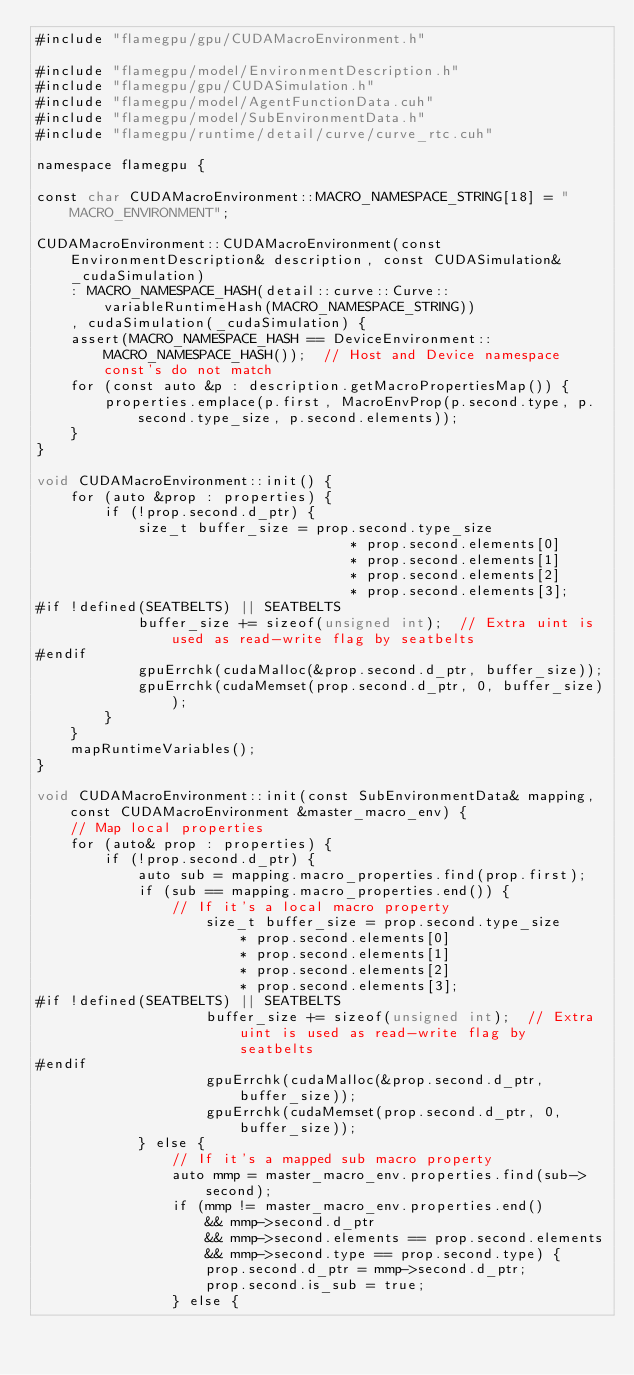<code> <loc_0><loc_0><loc_500><loc_500><_Cuda_>#include "flamegpu/gpu/CUDAMacroEnvironment.h"

#include "flamegpu/model/EnvironmentDescription.h"
#include "flamegpu/gpu/CUDASimulation.h"
#include "flamegpu/model/AgentFunctionData.cuh"
#include "flamegpu/model/SubEnvironmentData.h"
#include "flamegpu/runtime/detail/curve/curve_rtc.cuh"

namespace flamegpu {

const char CUDAMacroEnvironment::MACRO_NAMESPACE_STRING[18] = "MACRO_ENVIRONMENT";

CUDAMacroEnvironment::CUDAMacroEnvironment(const EnvironmentDescription& description, const CUDASimulation& _cudaSimulation)
    : MACRO_NAMESPACE_HASH(detail::curve::Curve::variableRuntimeHash(MACRO_NAMESPACE_STRING))
    , cudaSimulation(_cudaSimulation) {
    assert(MACRO_NAMESPACE_HASH == DeviceEnvironment::MACRO_NAMESPACE_HASH());  // Host and Device namespace const's do not match
    for (const auto &p : description.getMacroPropertiesMap()) {
        properties.emplace(p.first, MacroEnvProp(p.second.type, p.second.type_size, p.second.elements));
    }
}

void CUDAMacroEnvironment::init() {
    for (auto &prop : properties) {
        if (!prop.second.d_ptr) {
            size_t buffer_size = prop.second.type_size
                                     * prop.second.elements[0]
                                     * prop.second.elements[1]
                                     * prop.second.elements[2]
                                     * prop.second.elements[3];
#if !defined(SEATBELTS) || SEATBELTS
            buffer_size += sizeof(unsigned int);  // Extra uint is used as read-write flag by seatbelts
#endif
            gpuErrchk(cudaMalloc(&prop.second.d_ptr, buffer_size));
            gpuErrchk(cudaMemset(prop.second.d_ptr, 0, buffer_size));
        }
    }
    mapRuntimeVariables();
}

void CUDAMacroEnvironment::init(const SubEnvironmentData& mapping, const CUDAMacroEnvironment &master_macro_env) {
    // Map local properties
    for (auto& prop : properties) {
        if (!prop.second.d_ptr) {
            auto sub = mapping.macro_properties.find(prop.first);
            if (sub == mapping.macro_properties.end()) {
                // If it's a local macro property
                    size_t buffer_size = prop.second.type_size
                        * prop.second.elements[0]
                        * prop.second.elements[1]
                        * prop.second.elements[2]
                        * prop.second.elements[3];
#if !defined(SEATBELTS) || SEATBELTS
                    buffer_size += sizeof(unsigned int);  // Extra uint is used as read-write flag by seatbelts
#endif
                    gpuErrchk(cudaMalloc(&prop.second.d_ptr, buffer_size));
                    gpuErrchk(cudaMemset(prop.second.d_ptr, 0, buffer_size));
            } else {
                // If it's a mapped sub macro property
                auto mmp = master_macro_env.properties.find(sub->second);
                if (mmp != master_macro_env.properties.end()
                    && mmp->second.d_ptr
                    && mmp->second.elements == prop.second.elements
                    && mmp->second.type == prop.second.type) {
                    prop.second.d_ptr = mmp->second.d_ptr;
                    prop.second.is_sub = true;
                } else {</code> 